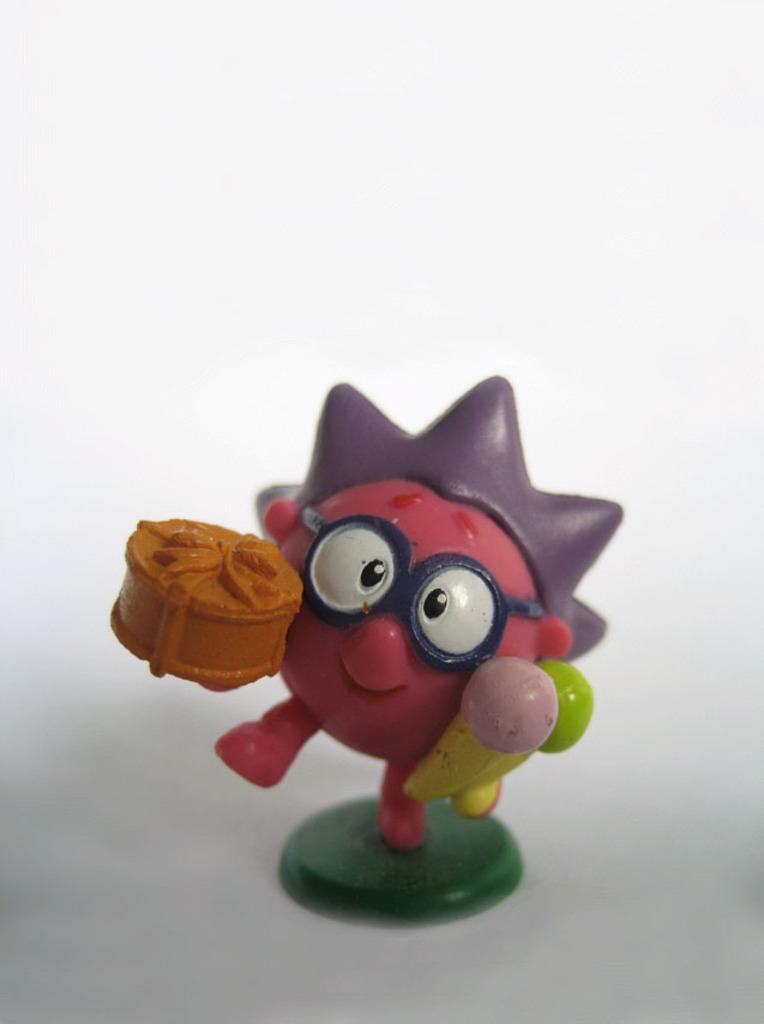What object is present in the image? There is a toy in the image. Where is the toy located? The toy is on a white surface. What color is the background of the image? The background of the image is white. What type of cloth is draped over the toy in the image? There is no cloth present in the image; the toy is on a white surface. What color is the silver object next to the toy in the image? There is no silver object present in the image; only the toy and the white surface are visible. 